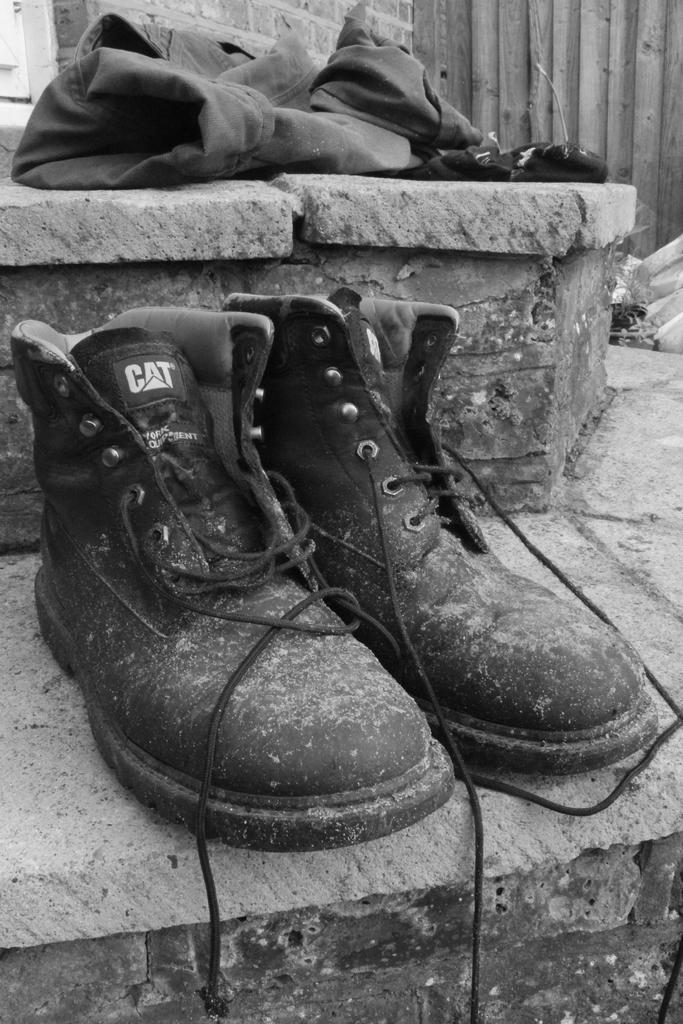What objects are on the stairs in the image? There are shoes and some cloth on the stairs in the image. What type of mist can be seen surrounding the shoes on the stairs in the image? There is no mist present in the image; it only shows shoes and cloth on the stairs. 